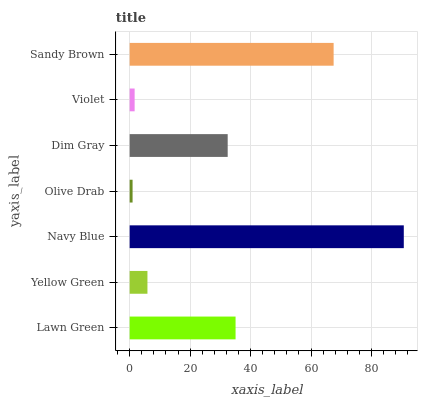Is Olive Drab the minimum?
Answer yes or no. Yes. Is Navy Blue the maximum?
Answer yes or no. Yes. Is Yellow Green the minimum?
Answer yes or no. No. Is Yellow Green the maximum?
Answer yes or no. No. Is Lawn Green greater than Yellow Green?
Answer yes or no. Yes. Is Yellow Green less than Lawn Green?
Answer yes or no. Yes. Is Yellow Green greater than Lawn Green?
Answer yes or no. No. Is Lawn Green less than Yellow Green?
Answer yes or no. No. Is Dim Gray the high median?
Answer yes or no. Yes. Is Dim Gray the low median?
Answer yes or no. Yes. Is Navy Blue the high median?
Answer yes or no. No. Is Navy Blue the low median?
Answer yes or no. No. 